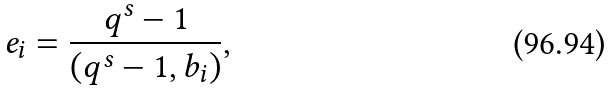<formula> <loc_0><loc_0><loc_500><loc_500>e _ { i } = \frac { q ^ { s } - 1 } { ( q ^ { s } - 1 , b _ { i } ) } ,</formula> 